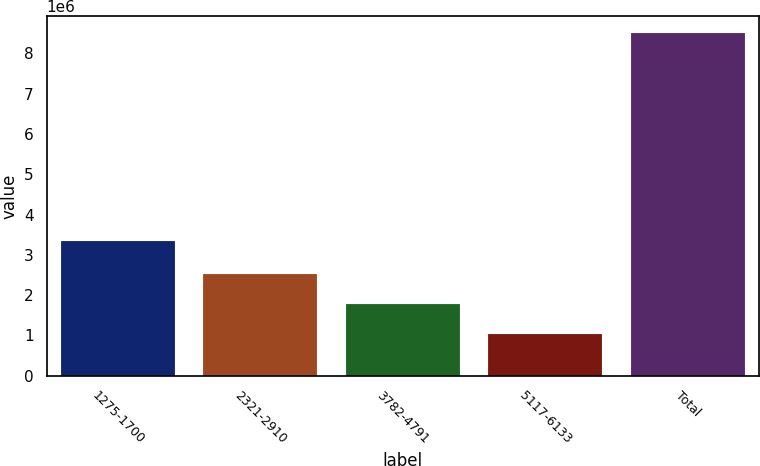Convert chart to OTSL. <chart><loc_0><loc_0><loc_500><loc_500><bar_chart><fcel>1275-1700<fcel>2321-2910<fcel>3782-4791<fcel>5117-6133<fcel>Total<nl><fcel>3.35305e+06<fcel>2.51709e+06<fcel>1.76949e+06<fcel>1.0219e+06<fcel>8.49787e+06<nl></chart> 